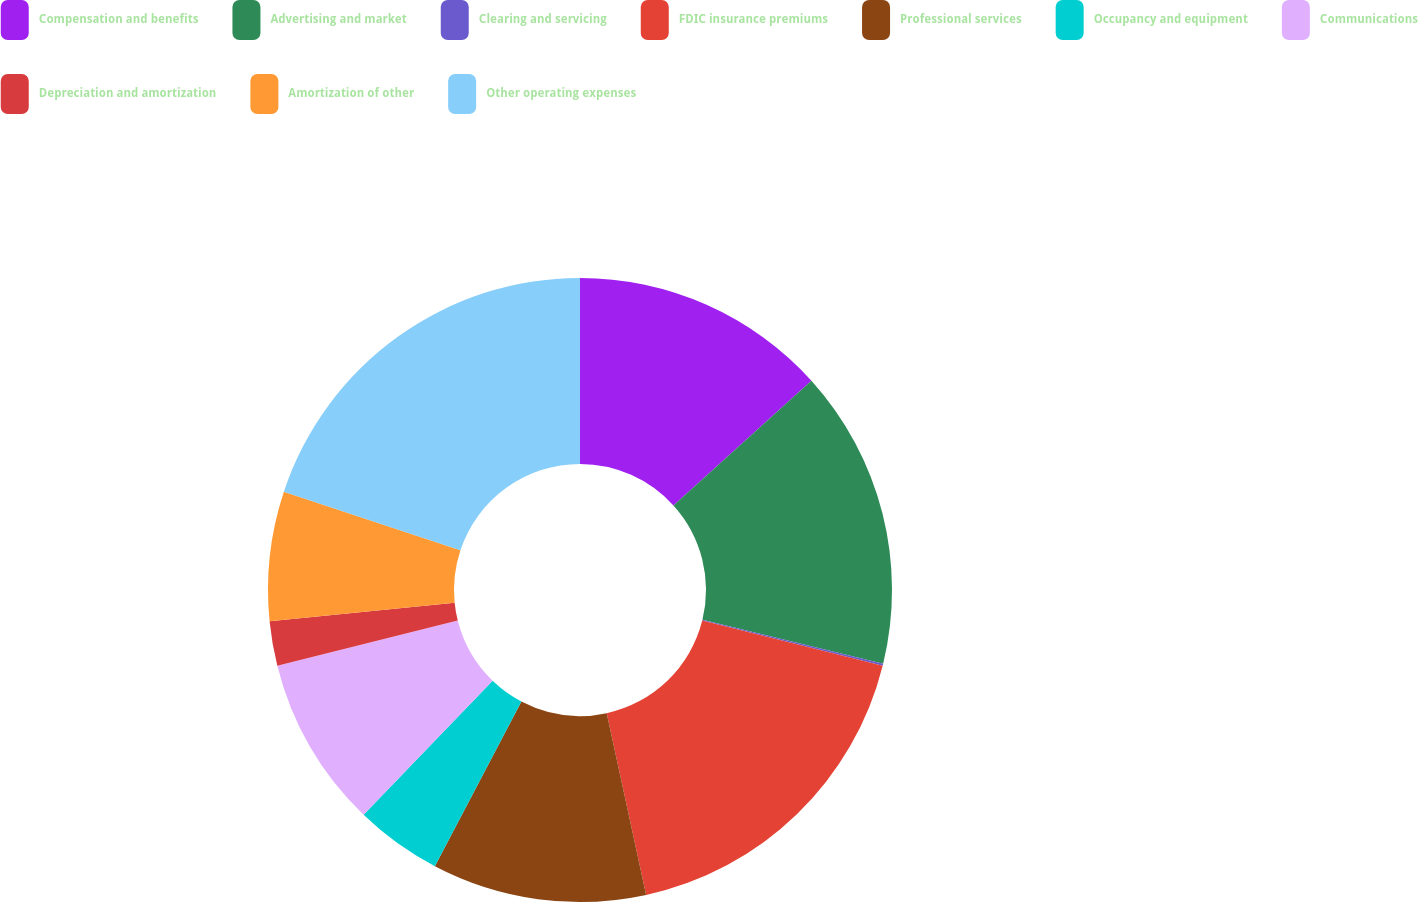<chart> <loc_0><loc_0><loc_500><loc_500><pie_chart><fcel>Compensation and benefits<fcel>Advertising and market<fcel>Clearing and servicing<fcel>FDIC insurance premiums<fcel>Professional services<fcel>Occupancy and equipment<fcel>Communications<fcel>Depreciation and amortization<fcel>Amortization of other<fcel>Other operating expenses<nl><fcel>13.3%<fcel>15.5%<fcel>0.1%<fcel>17.7%<fcel>11.1%<fcel>4.5%<fcel>8.9%<fcel>2.3%<fcel>6.7%<fcel>19.9%<nl></chart> 